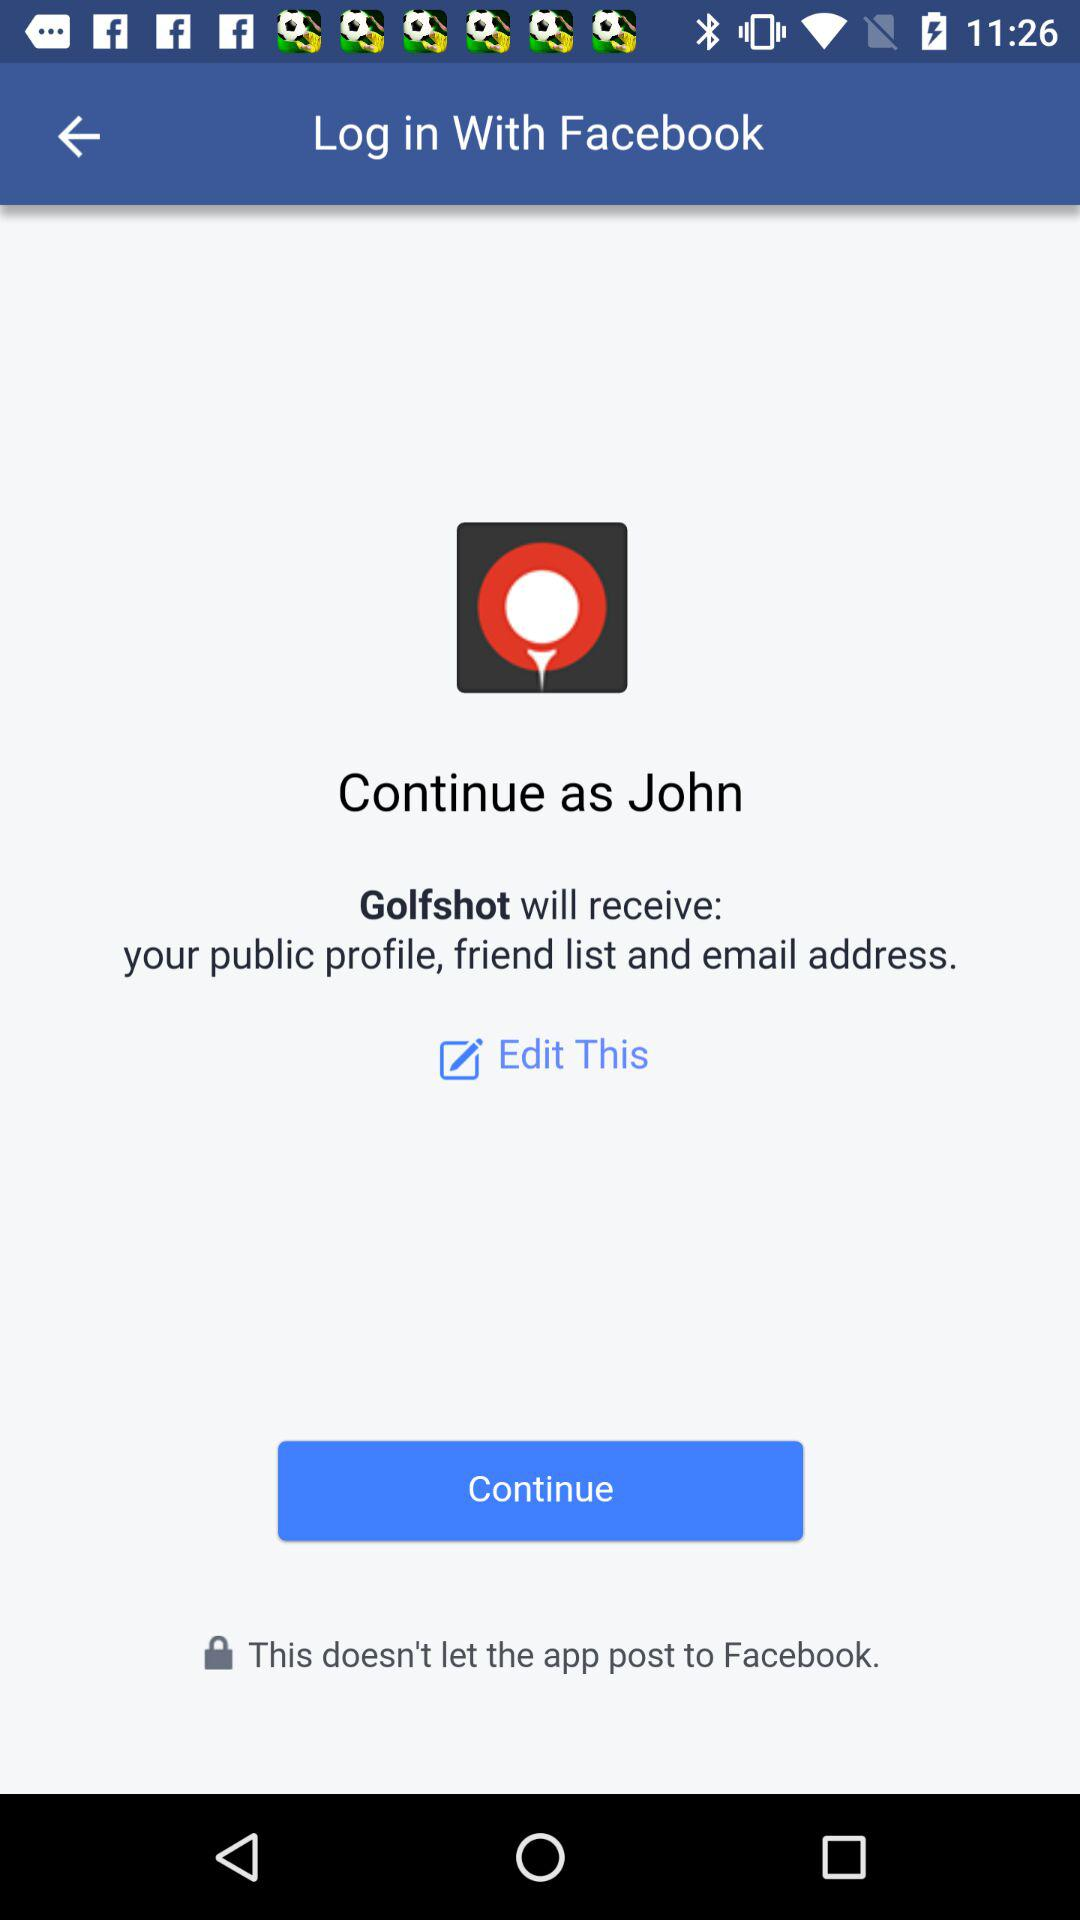What application can be used to log in to the profile? The application that can be used to log in to the profile is "Facebook". 